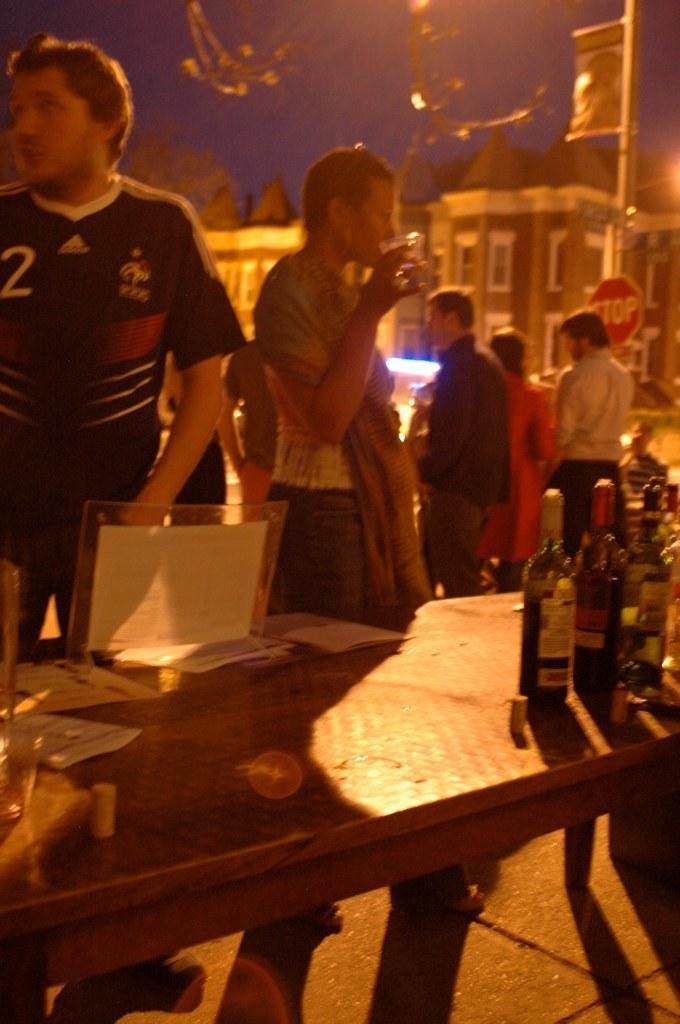Can you describe this image briefly? The image is taken at night time there are few people standing ,in front of them there is a table and on the table there are some bottles ,in the background there is a building sky and trees. 